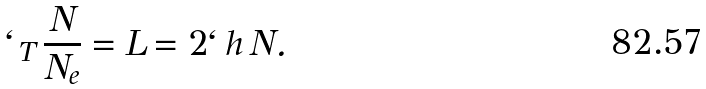Convert formula to latex. <formula><loc_0><loc_0><loc_500><loc_500>\ell _ { T } \, \frac { N } { N _ { e } } = L = 2 \ell \, h \, N .</formula> 